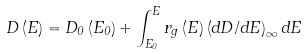Convert formula to latex. <formula><loc_0><loc_0><loc_500><loc_500>D \left ( E \right ) = D _ { 0 } \left ( E _ { 0 } \right ) + \int _ { E _ { 0 } } ^ { E } r _ { g } \left ( E \right ) \left ( d D / d E \right ) _ { \infty } d E</formula> 